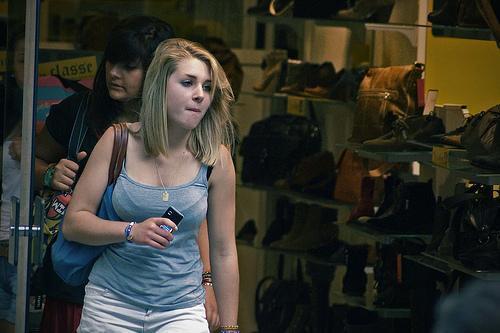How many women can be seen?
Give a very brief answer. 2. 